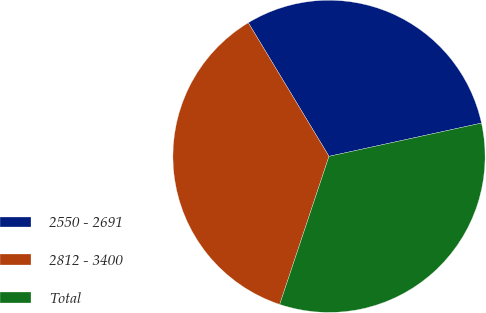Convert chart. <chart><loc_0><loc_0><loc_500><loc_500><pie_chart><fcel>2550 - 2691<fcel>2812 - 3400<fcel>Total<nl><fcel>30.23%<fcel>36.24%<fcel>33.53%<nl></chart> 